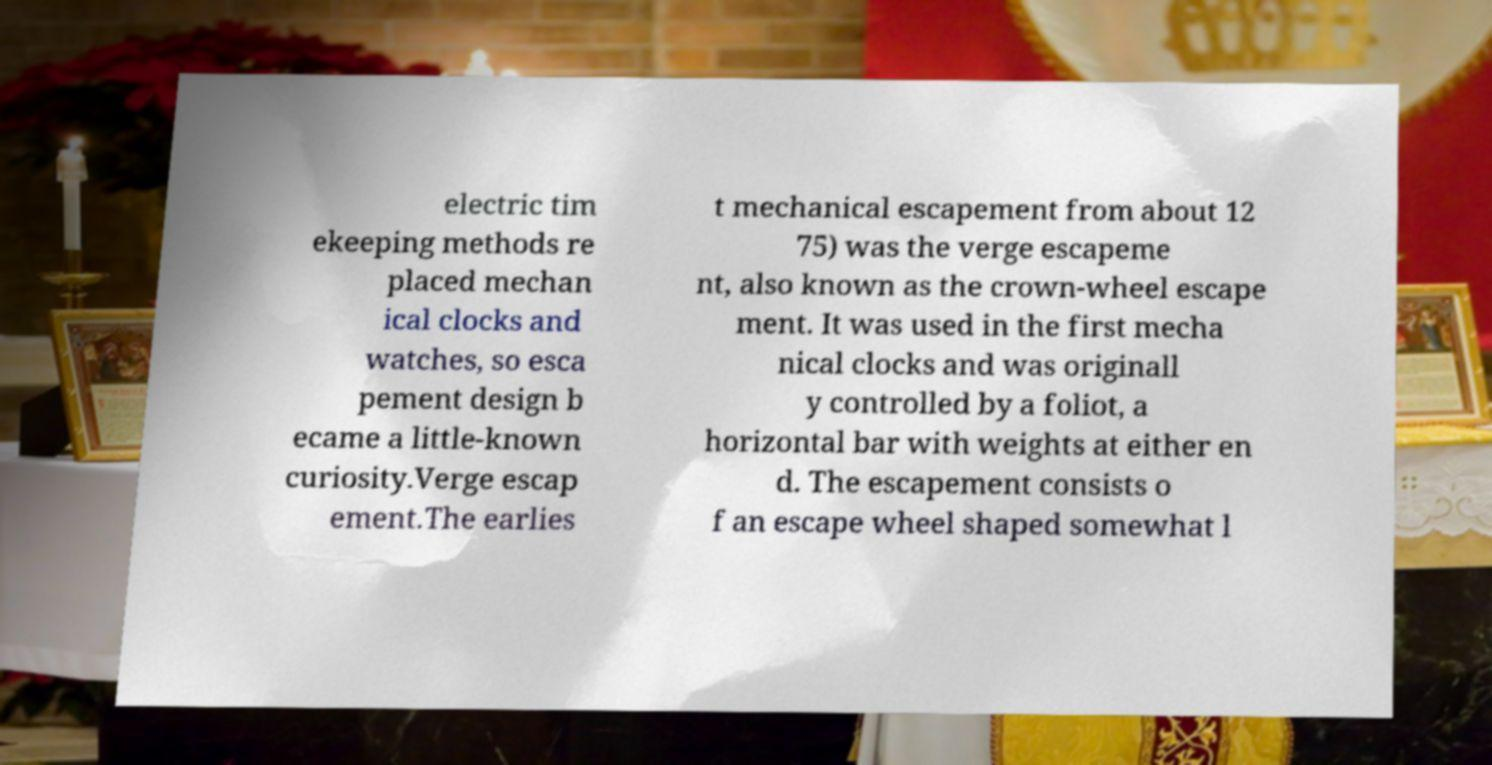Could you assist in decoding the text presented in this image and type it out clearly? electric tim ekeeping methods re placed mechan ical clocks and watches, so esca pement design b ecame a little-known curiosity.Verge escap ement.The earlies t mechanical escapement from about 12 75) was the verge escapeme nt, also known as the crown-wheel escape ment. It was used in the first mecha nical clocks and was originall y controlled by a foliot, a horizontal bar with weights at either en d. The escapement consists o f an escape wheel shaped somewhat l 